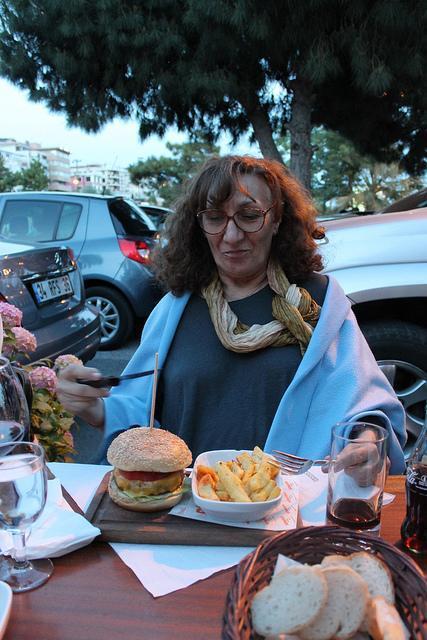How many cars are there?
Give a very brief answer. 2. How many bowls are there?
Give a very brief answer. 2. How many giraffes are there in the grass?
Give a very brief answer. 0. 